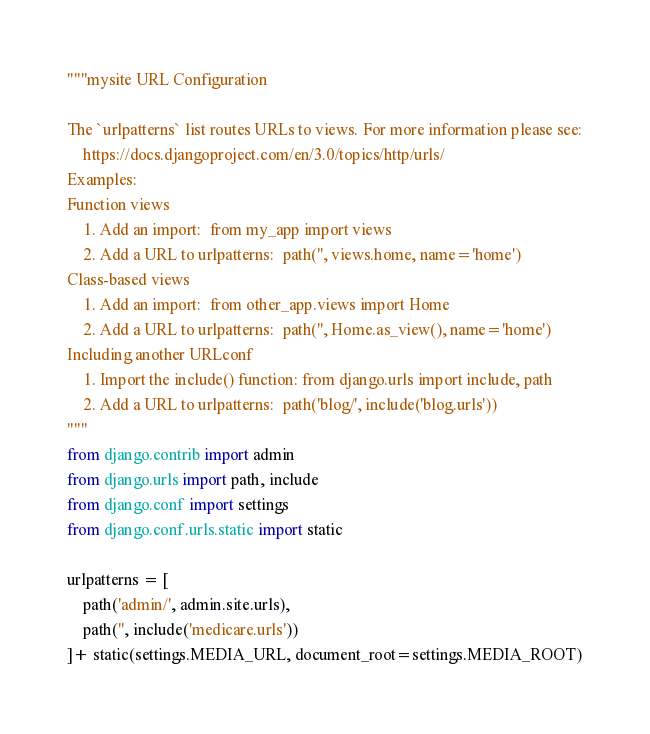Convert code to text. <code><loc_0><loc_0><loc_500><loc_500><_Python_>"""mysite URL Configuration

The `urlpatterns` list routes URLs to views. For more information please see:
    https://docs.djangoproject.com/en/3.0/topics/http/urls/
Examples:
Function views
    1. Add an import:  from my_app import views
    2. Add a URL to urlpatterns:  path('', views.home, name='home')
Class-based views
    1. Add an import:  from other_app.views import Home
    2. Add a URL to urlpatterns:  path('', Home.as_view(), name='home')
Including another URLconf
    1. Import the include() function: from django.urls import include, path
    2. Add a URL to urlpatterns:  path('blog/', include('blog.urls'))
"""
from django.contrib import admin
from django.urls import path, include
from django.conf import settings
from django.conf.urls.static import static

urlpatterns = [
    path('admin/', admin.site.urls),
    path('', include('medicare.urls'))
]+ static(settings.MEDIA_URL, document_root=settings.MEDIA_ROOT)
</code> 